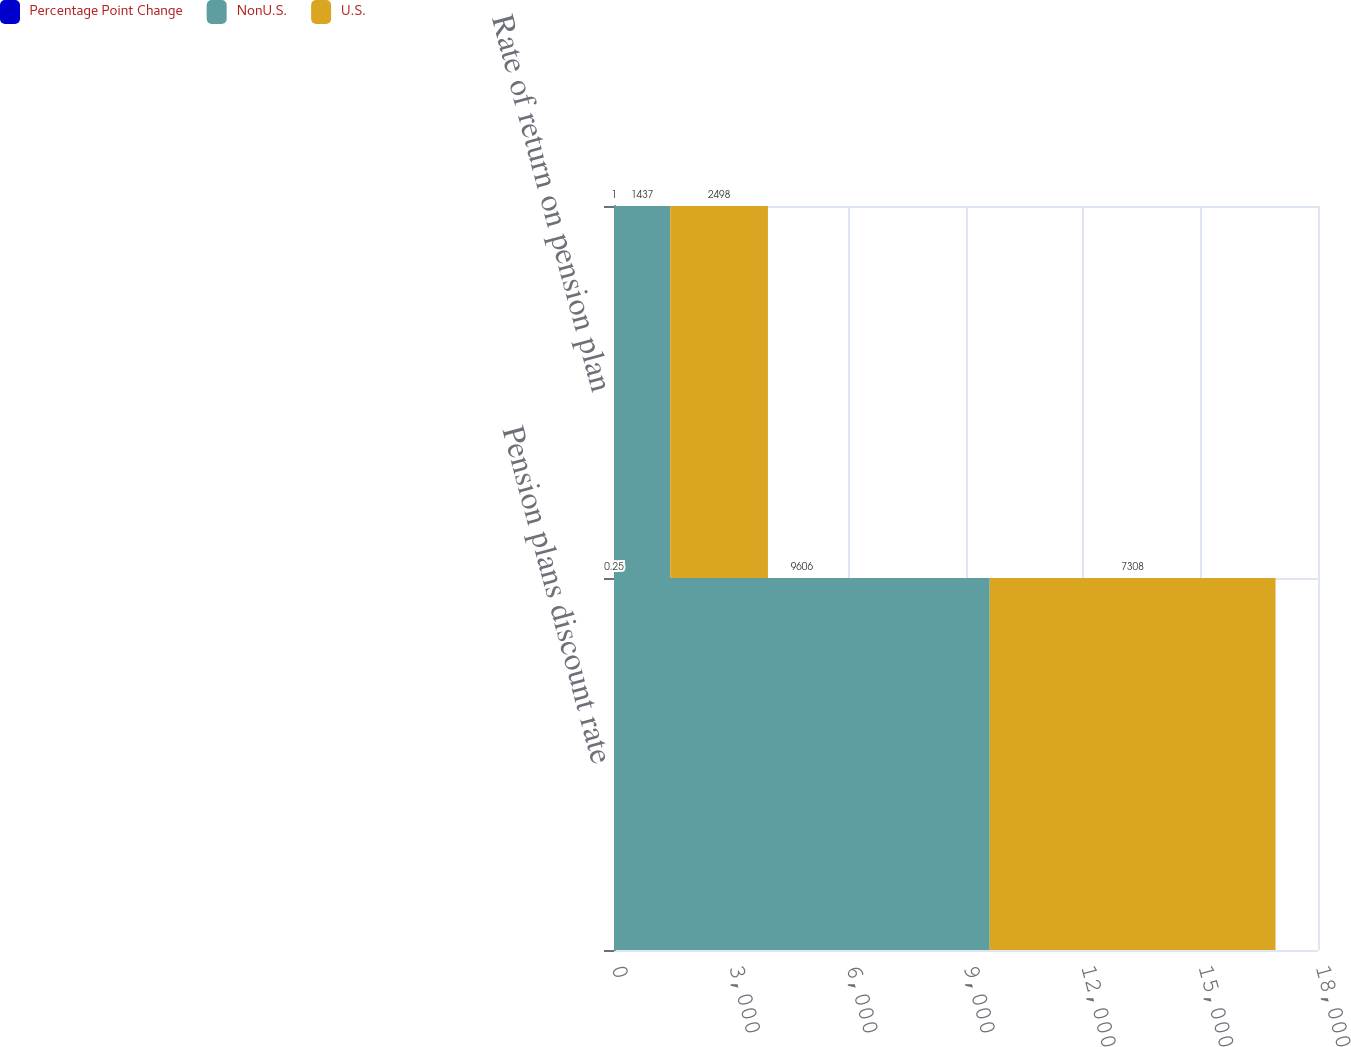Convert chart to OTSL. <chart><loc_0><loc_0><loc_500><loc_500><stacked_bar_chart><ecel><fcel>Pension plans discount rate<fcel>Rate of return on pension plan<nl><fcel>Percentage Point Change<fcel>0.25<fcel>1<nl><fcel>NonU.S.<fcel>9606<fcel>1437<nl><fcel>U.S.<fcel>7308<fcel>2498<nl></chart> 